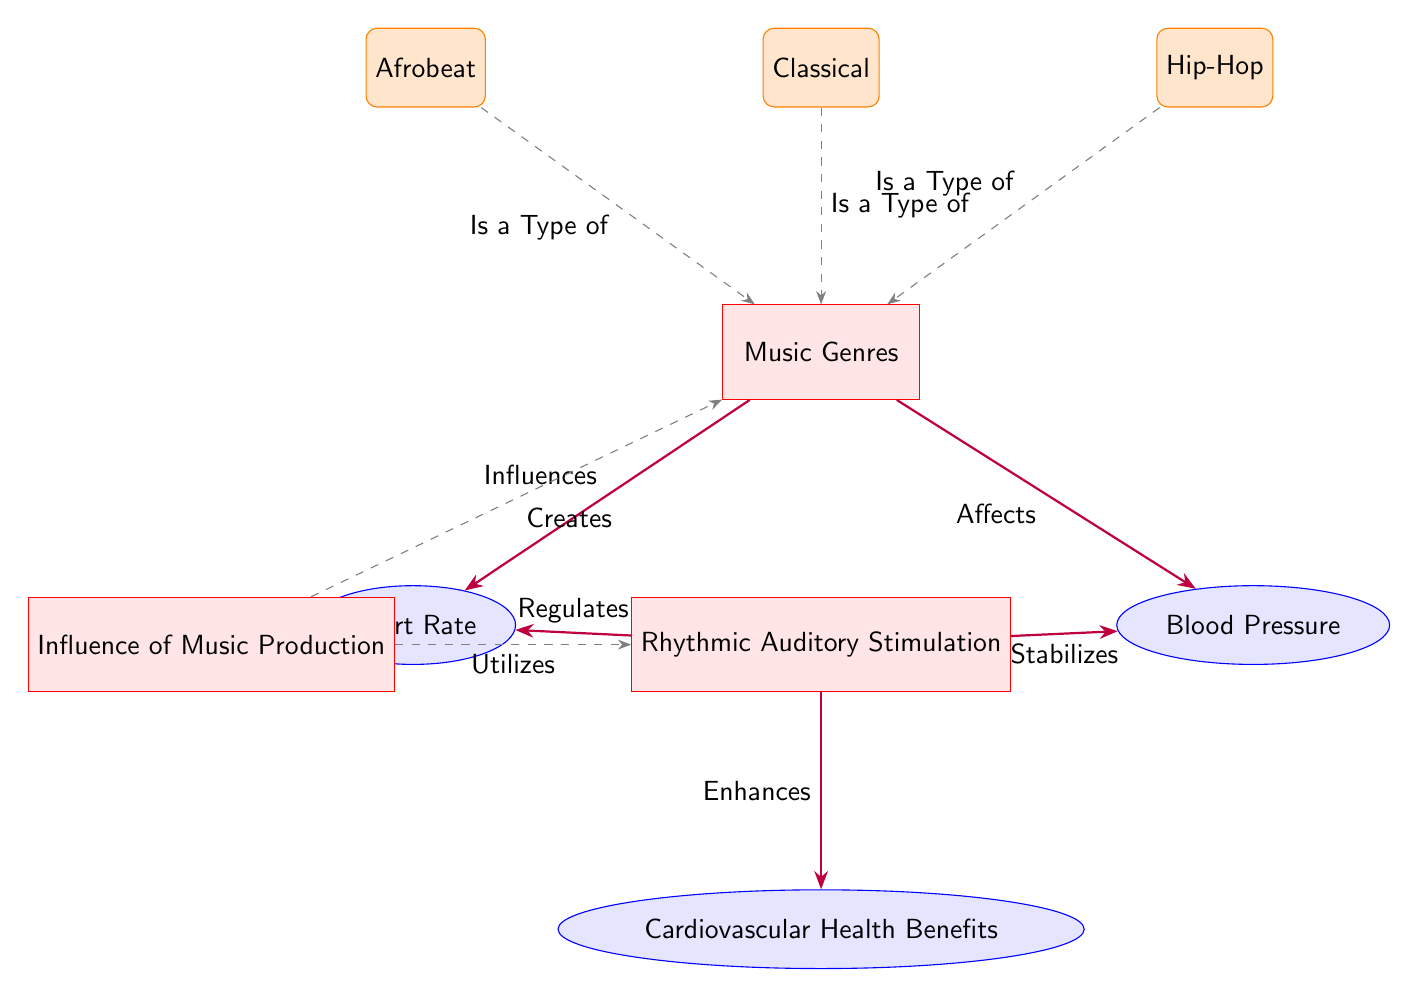What are the three music genres listed in the diagram? The diagram lists three different music genres: Afrobeat, Classical, and Hip-Hop, each represented as a separate node connected to the main music genres node.
Answer: Afrobeat, Classical, Hip-Hop How does rhythmic auditory stimulation influence heart rate? According to the diagram, rhythmic auditory stimulation regulated the heart rate, indicating a psychological or physiological response to rhythm.
Answer: Regulates What is the primary effect of music genres on blood pressure? The diagram indicates that music genres affect blood pressure, showcasing the impact that different styles of music can have on this cardiovascular measure.
Answer: Affects How is rhythmic auditory stimulation connected to cardiovascular health benefits? The diagram shows that rhythmic auditory stimulation enhances cardiovascular health benefits, indicating a positive outcome from using rhythm in therapy.
Answer: Enhances Which node indicates the influence of music production? The diagram explicitly labels the node "Influence of Music Production," highlighting its role in the context of music and health sciences.
Answer: Influence of Music Production What type of relationship do the music genres have with rhythmic auditory stimulation? The diagram illustrates a direct connection where "Influence of Music Production" creates music genres and utilizes rhythmic auditory stimulation, showing the relationships maintained within the context.
Answer: Creates, Utilizes What node relates to both heart rate and blood pressure in the diagram? The node labeled "Rhythmic Auditory Stimulation" connects to both heart rate and blood pressure, indicating its direct physiological effects on these cardiovascular measures.
Answer: Rhythmic Auditory Stimulation How many nodes are connected to the "Music Genres" node? The diagram connects three music genres and two concepts (heart rate and blood pressure) to the "Music Genres" node, totaling five connections.
Answer: Five What therapeutic role is highlighted in the diagram? The role highlighted is "Rhythmic Auditory Stimulation," which is specifically mentioned as being used to benefit cardiovascular health, showcasing its therapeutic implications.
Answer: Rhythmic Auditory Stimulation 